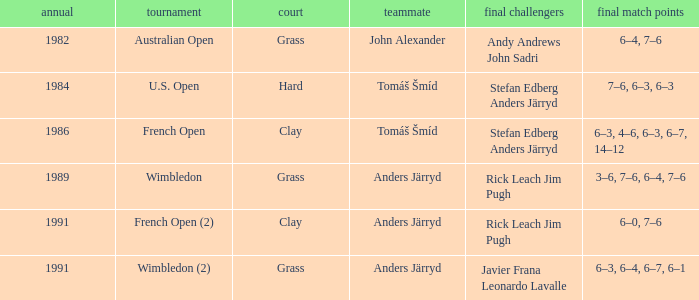What was the surface when he played with John Alexander?  Grass. Would you mind parsing the complete table? {'header': ['annual', 'tournament', 'court', 'teammate', 'final challengers', 'final match points'], 'rows': [['1982', 'Australian Open', 'Grass', 'John Alexander', 'Andy Andrews John Sadri', '6–4, 7–6'], ['1984', 'U.S. Open', 'Hard', 'Tomáš Šmíd', 'Stefan Edberg Anders Järryd', '7–6, 6–3, 6–3'], ['1986', 'French Open', 'Clay', 'Tomáš Šmíd', 'Stefan Edberg Anders Järryd', '6–3, 4–6, 6–3, 6–7, 14–12'], ['1989', 'Wimbledon', 'Grass', 'Anders Järryd', 'Rick Leach Jim Pugh', '3–6, 7–6, 6–4, 7–6'], ['1991', 'French Open (2)', 'Clay', 'Anders Järryd', 'Rick Leach Jim Pugh', '6–0, 7–6'], ['1991', 'Wimbledon (2)', 'Grass', 'Anders Järryd', 'Javier Frana Leonardo Lavalle', '6–3, 6–4, 6–7, 6–1']]} 